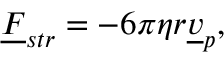<formula> <loc_0><loc_0><loc_500><loc_500>\underline { F } _ { s t r } = - 6 \pi \eta r \underline { v } _ { p } ,</formula> 